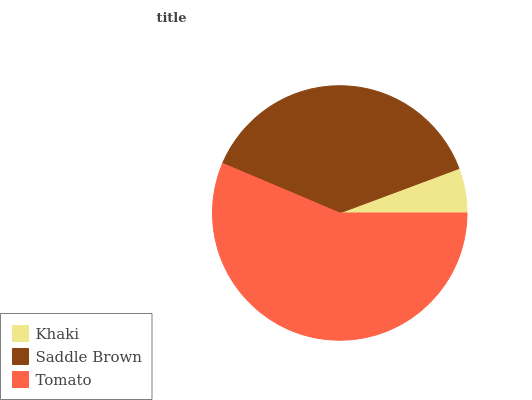Is Khaki the minimum?
Answer yes or no. Yes. Is Tomato the maximum?
Answer yes or no. Yes. Is Saddle Brown the minimum?
Answer yes or no. No. Is Saddle Brown the maximum?
Answer yes or no. No. Is Saddle Brown greater than Khaki?
Answer yes or no. Yes. Is Khaki less than Saddle Brown?
Answer yes or no. Yes. Is Khaki greater than Saddle Brown?
Answer yes or no. No. Is Saddle Brown less than Khaki?
Answer yes or no. No. Is Saddle Brown the high median?
Answer yes or no. Yes. Is Saddle Brown the low median?
Answer yes or no. Yes. Is Khaki the high median?
Answer yes or no. No. Is Tomato the low median?
Answer yes or no. No. 